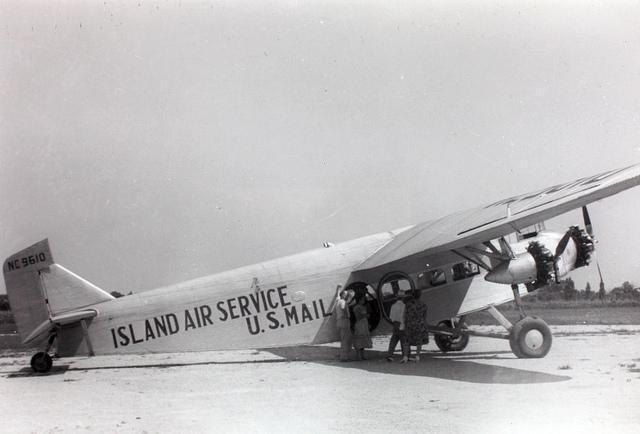How many people are shown here?
Give a very brief answer. 4. 